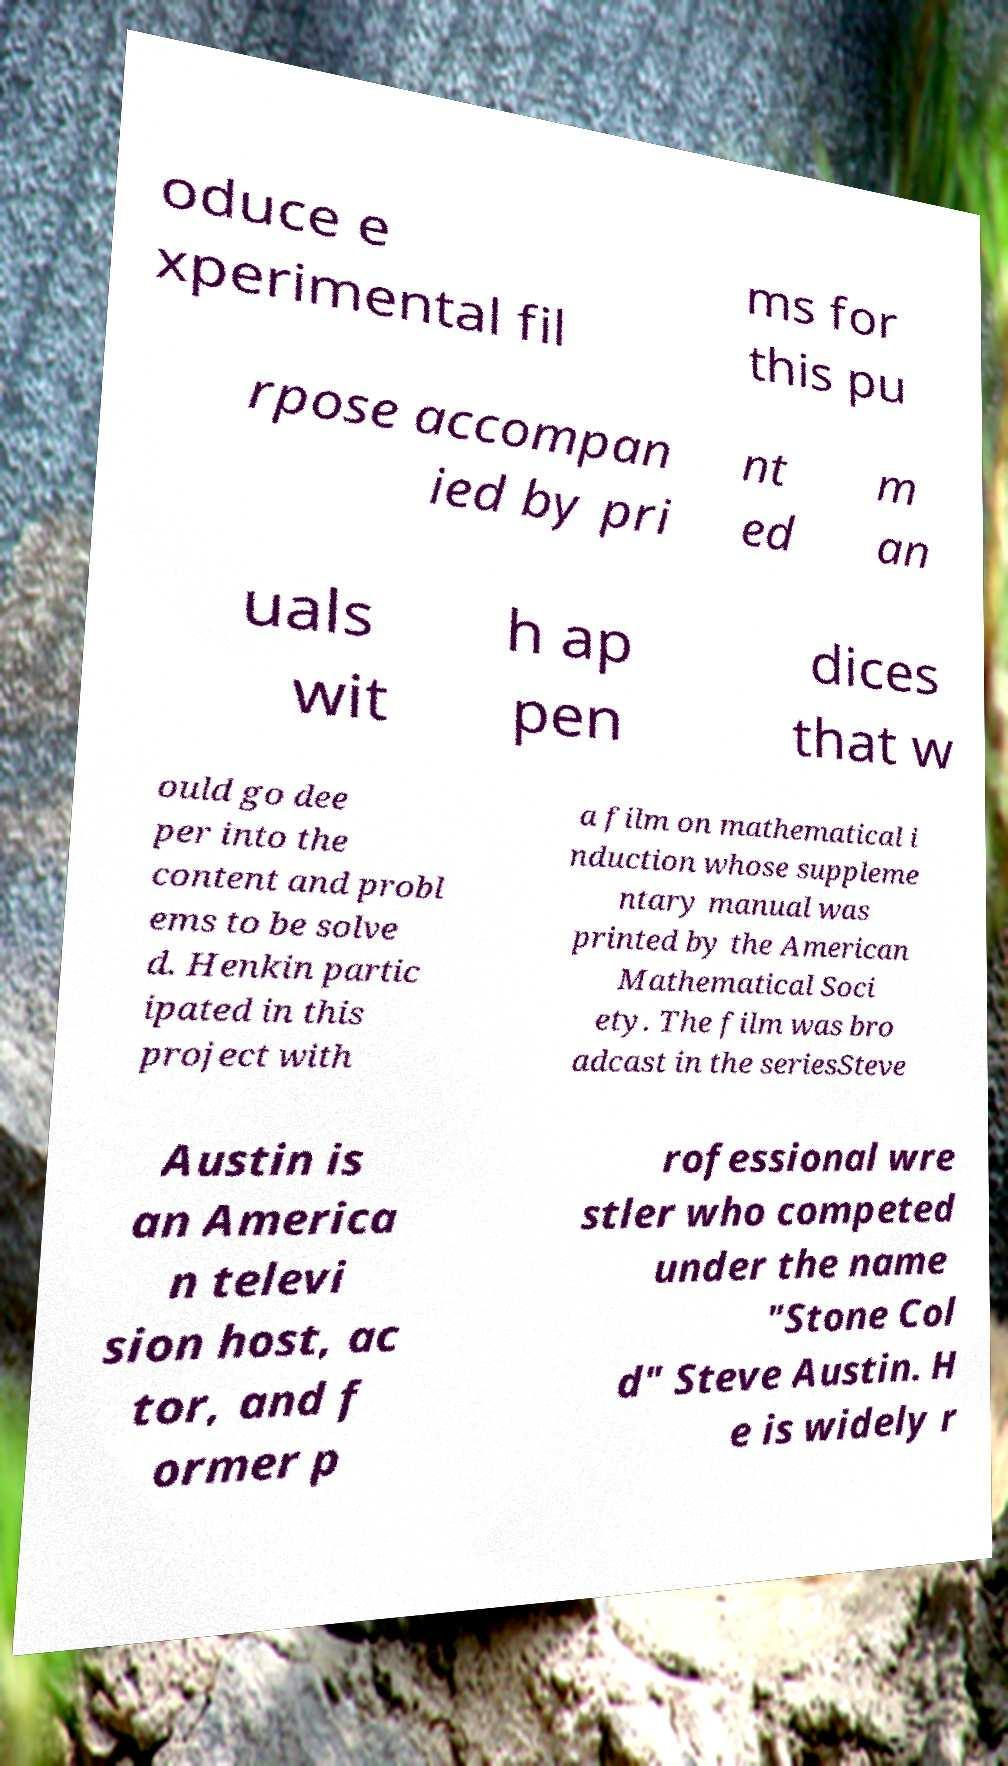Please identify and transcribe the text found in this image. oduce e xperimental fil ms for this pu rpose accompan ied by pri nt ed m an uals wit h ap pen dices that w ould go dee per into the content and probl ems to be solve d. Henkin partic ipated in this project with a film on mathematical i nduction whose suppleme ntary manual was printed by the American Mathematical Soci ety. The film was bro adcast in the seriesSteve Austin is an America n televi sion host, ac tor, and f ormer p rofessional wre stler who competed under the name "Stone Col d" Steve Austin. H e is widely r 